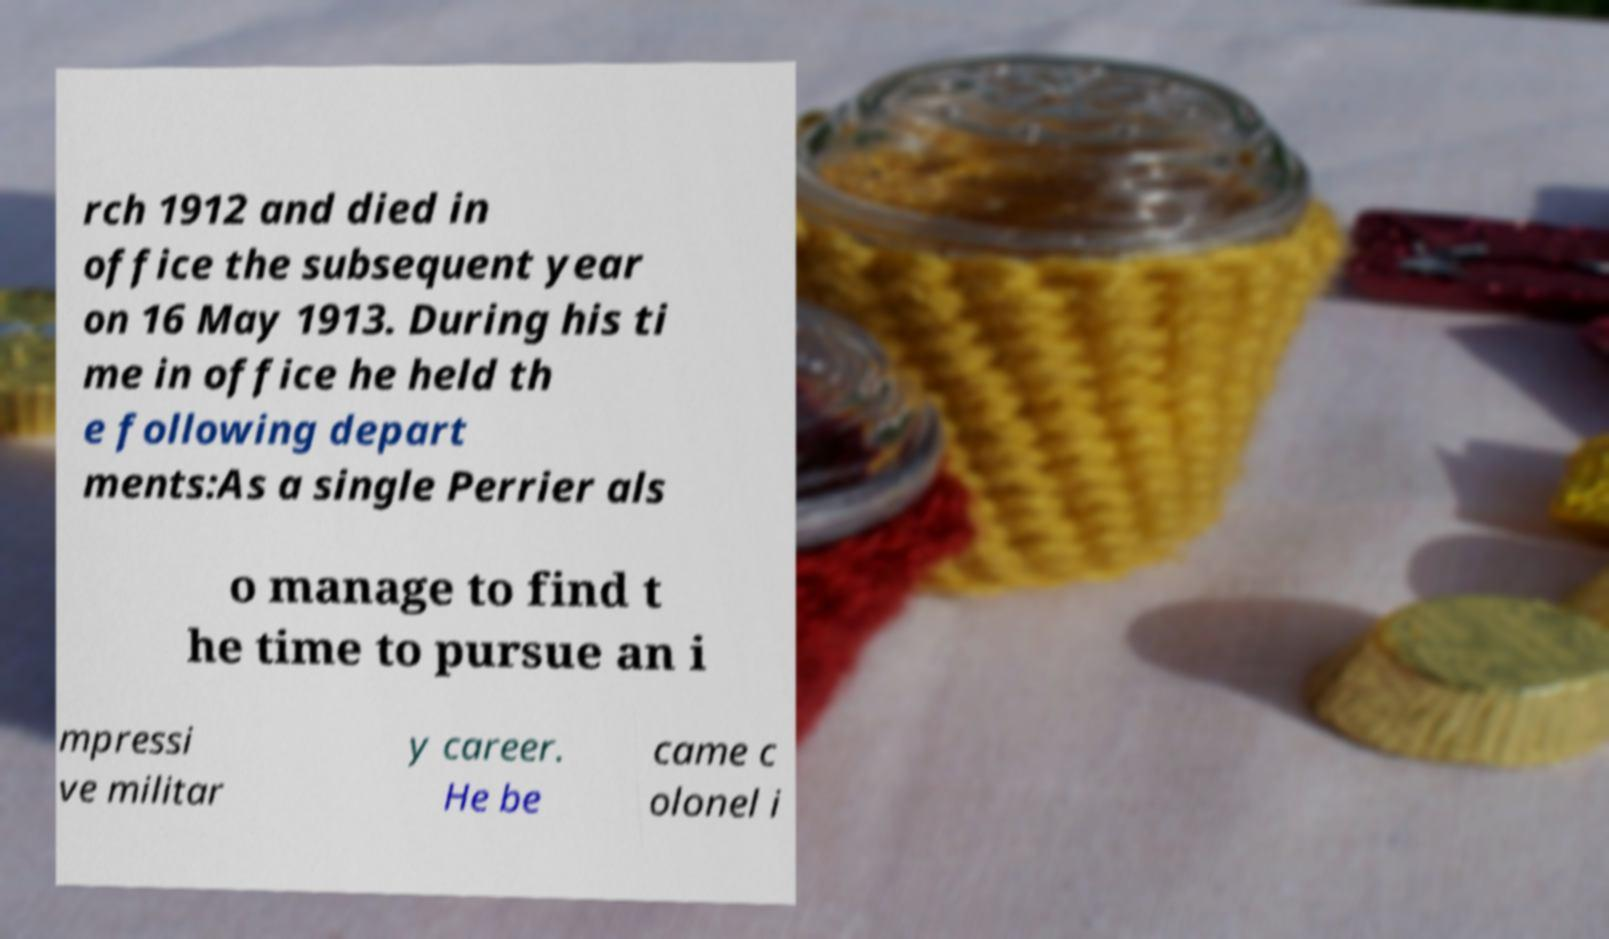There's text embedded in this image that I need extracted. Can you transcribe it verbatim? rch 1912 and died in office the subsequent year on 16 May 1913. During his ti me in office he held th e following depart ments:As a single Perrier als o manage to find t he time to pursue an i mpressi ve militar y career. He be came c olonel i 